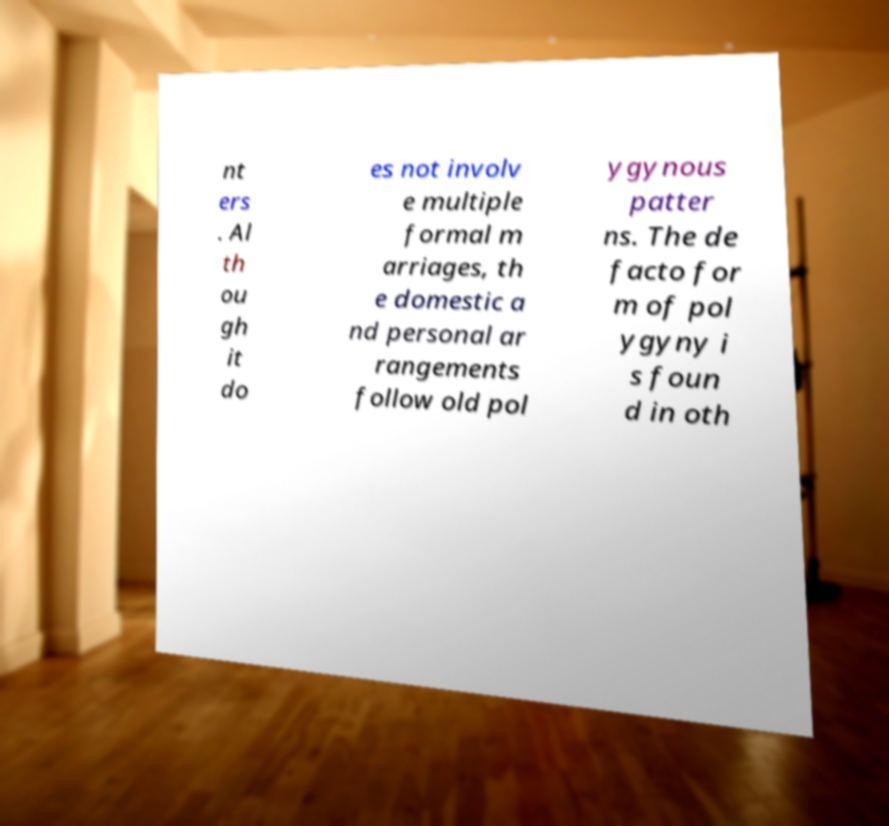For documentation purposes, I need the text within this image transcribed. Could you provide that? nt ers . Al th ou gh it do es not involv e multiple formal m arriages, th e domestic a nd personal ar rangements follow old pol ygynous patter ns. The de facto for m of pol ygyny i s foun d in oth 